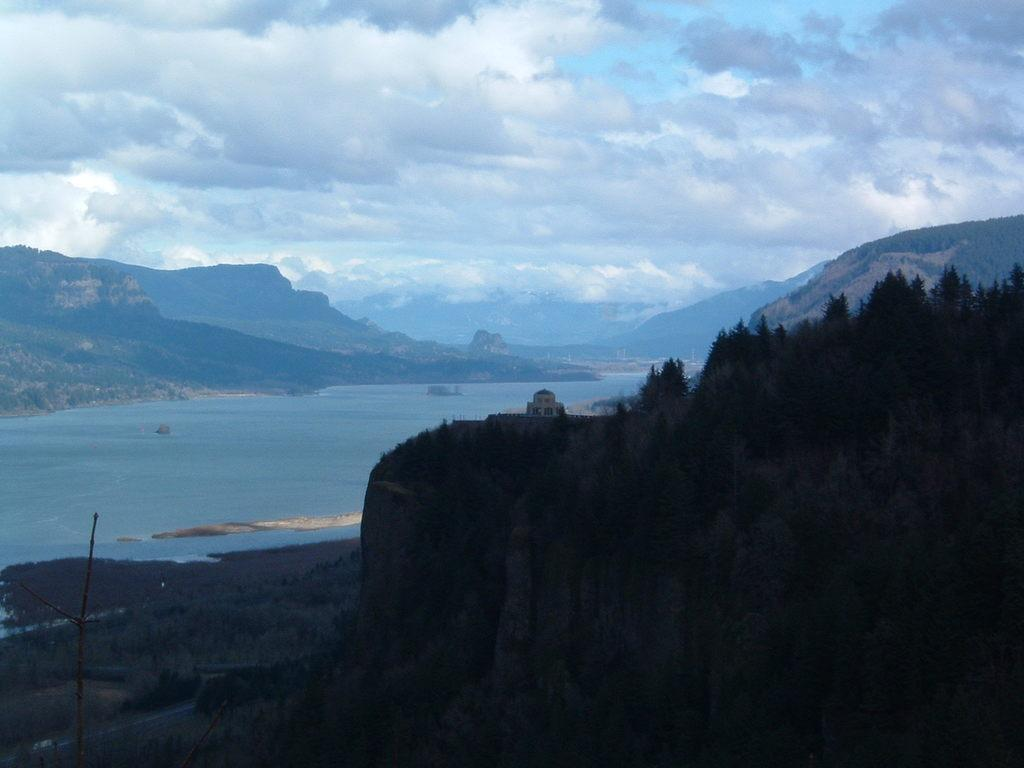What type of vegetation can be seen in the image? There are trees in the image. What natural element is visible in the image? There is water visible in the image. What can be seen in the distance in the image? There are hills in the background of the image. What is visible in the sky in the image? There are clouds visible in the background of the image. Where is the scarecrow playing basketball in the image? There is no scarecrow or basketball present in the image. How many family members can be seen in the image? There is no reference to a family or family members in the image. 